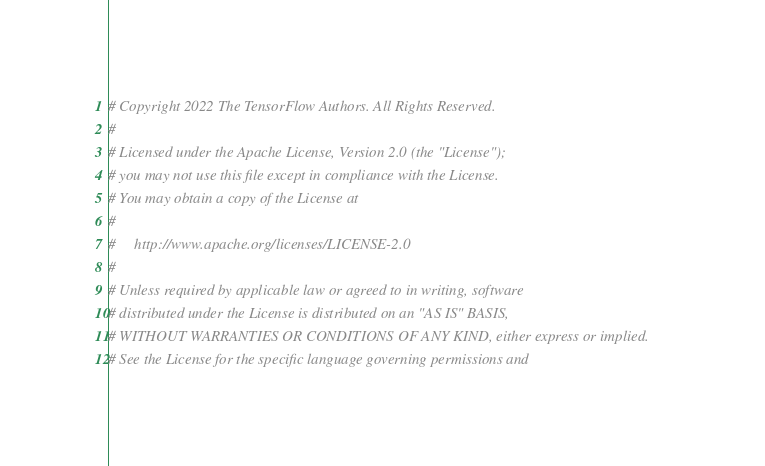Convert code to text. <code><loc_0><loc_0><loc_500><loc_500><_Python_># Copyright 2022 The TensorFlow Authors. All Rights Reserved.
#
# Licensed under the Apache License, Version 2.0 (the "License");
# you may not use this file except in compliance with the License.
# You may obtain a copy of the License at
#
#     http://www.apache.org/licenses/LICENSE-2.0
#
# Unless required by applicable law or agreed to in writing, software
# distributed under the License is distributed on an "AS IS" BASIS,
# WITHOUT WARRANTIES OR CONDITIONS OF ANY KIND, either express or implied.
# See the License for the specific language governing permissions and</code> 